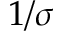<formula> <loc_0><loc_0><loc_500><loc_500>1 / \sigma</formula> 